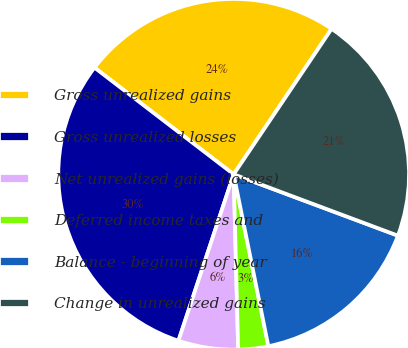Convert chart. <chart><loc_0><loc_0><loc_500><loc_500><pie_chart><fcel>Gross unrealized gains<fcel>Gross unrealized losses<fcel>Net unrealized gains (losses)<fcel>Deferred income taxes and<fcel>Balance - beginning of year<fcel>Change in unrealized gains<nl><fcel>24.02%<fcel>30.31%<fcel>5.51%<fcel>2.76%<fcel>16.14%<fcel>21.26%<nl></chart> 